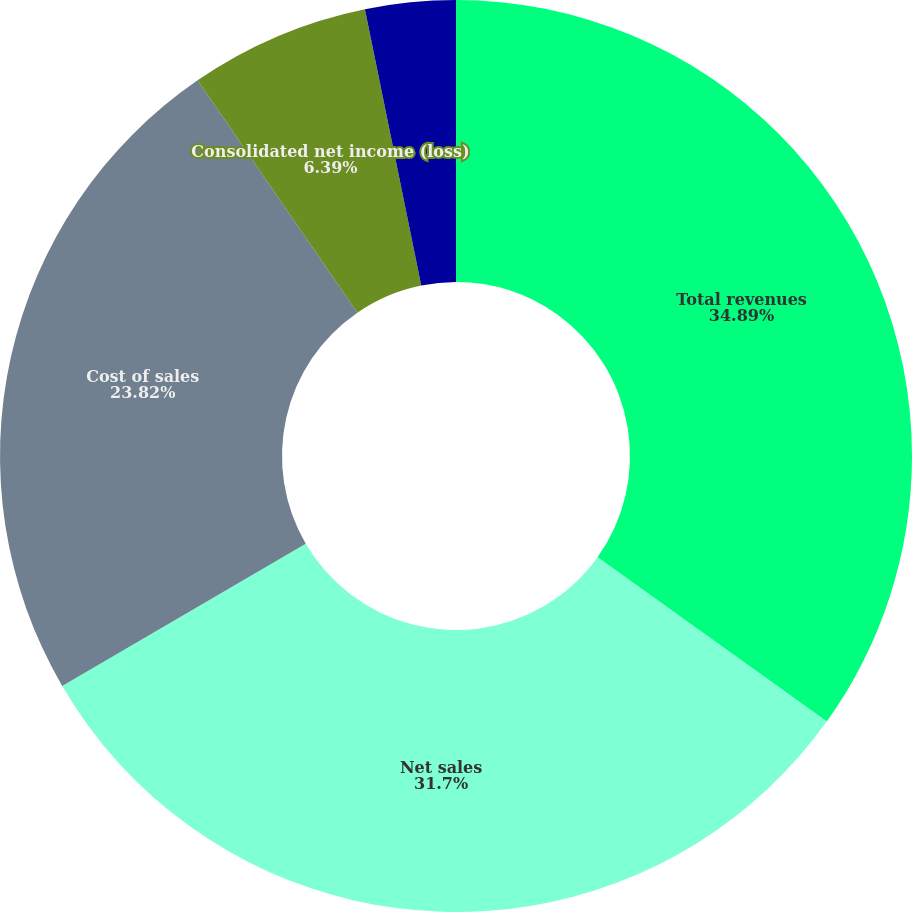Convert chart to OTSL. <chart><loc_0><loc_0><loc_500><loc_500><pie_chart><fcel>Total revenues<fcel>Net sales<fcel>Cost of sales<fcel>Consolidated net income (loss)<fcel>Basic net income (loss) per<fcel>Diluted net income (loss) per<nl><fcel>34.89%<fcel>31.7%<fcel>23.82%<fcel>6.39%<fcel>0.0%<fcel>3.2%<nl></chart> 